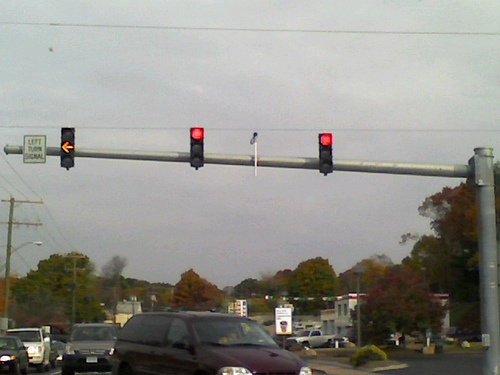Describe the objects in this image and their specific colors. I can see car in lightgray, black, and gray tones, car in lightgray, black, and gray tones, car in lightgray, black, gray, darkgray, and ivory tones, car in lightgray, black, gray, and darkgreen tones, and truck in lightgray, black, gray, and darkgray tones in this image. 